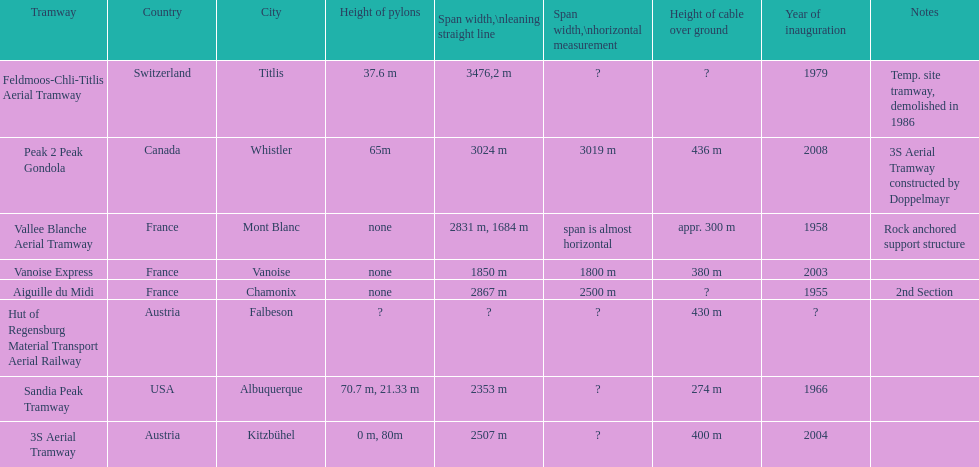Was the sandia peak tramway innagurate before or after the 3s aerial tramway? Before. 